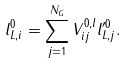<formula> <loc_0><loc_0><loc_500><loc_500>l _ { L , i } ^ { 0 } = \sum _ { j = 1 } ^ { N _ { G } } V _ { i j } ^ { 0 , l } l _ { L , j } ^ { \prime 0 } .</formula> 